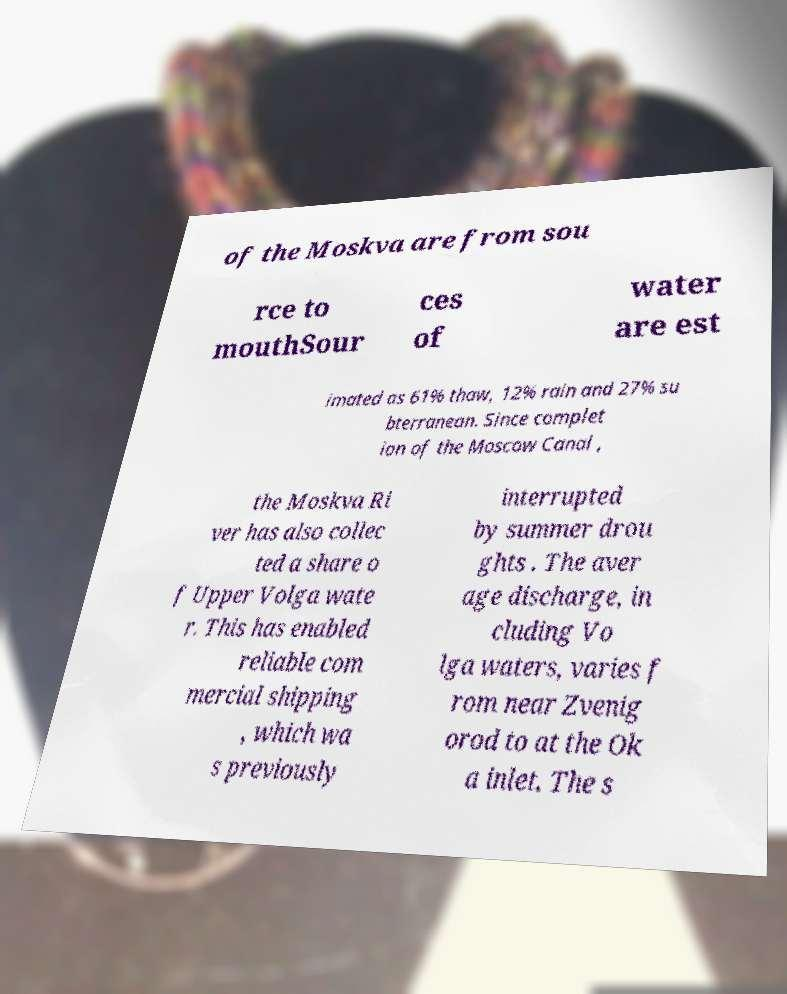Could you extract and type out the text from this image? of the Moskva are from sou rce to mouthSour ces of water are est imated as 61% thaw, 12% rain and 27% su bterranean. Since complet ion of the Moscow Canal , the Moskva Ri ver has also collec ted a share o f Upper Volga wate r. This has enabled reliable com mercial shipping , which wa s previously interrupted by summer drou ghts . The aver age discharge, in cluding Vo lga waters, varies f rom near Zvenig orod to at the Ok a inlet. The s 